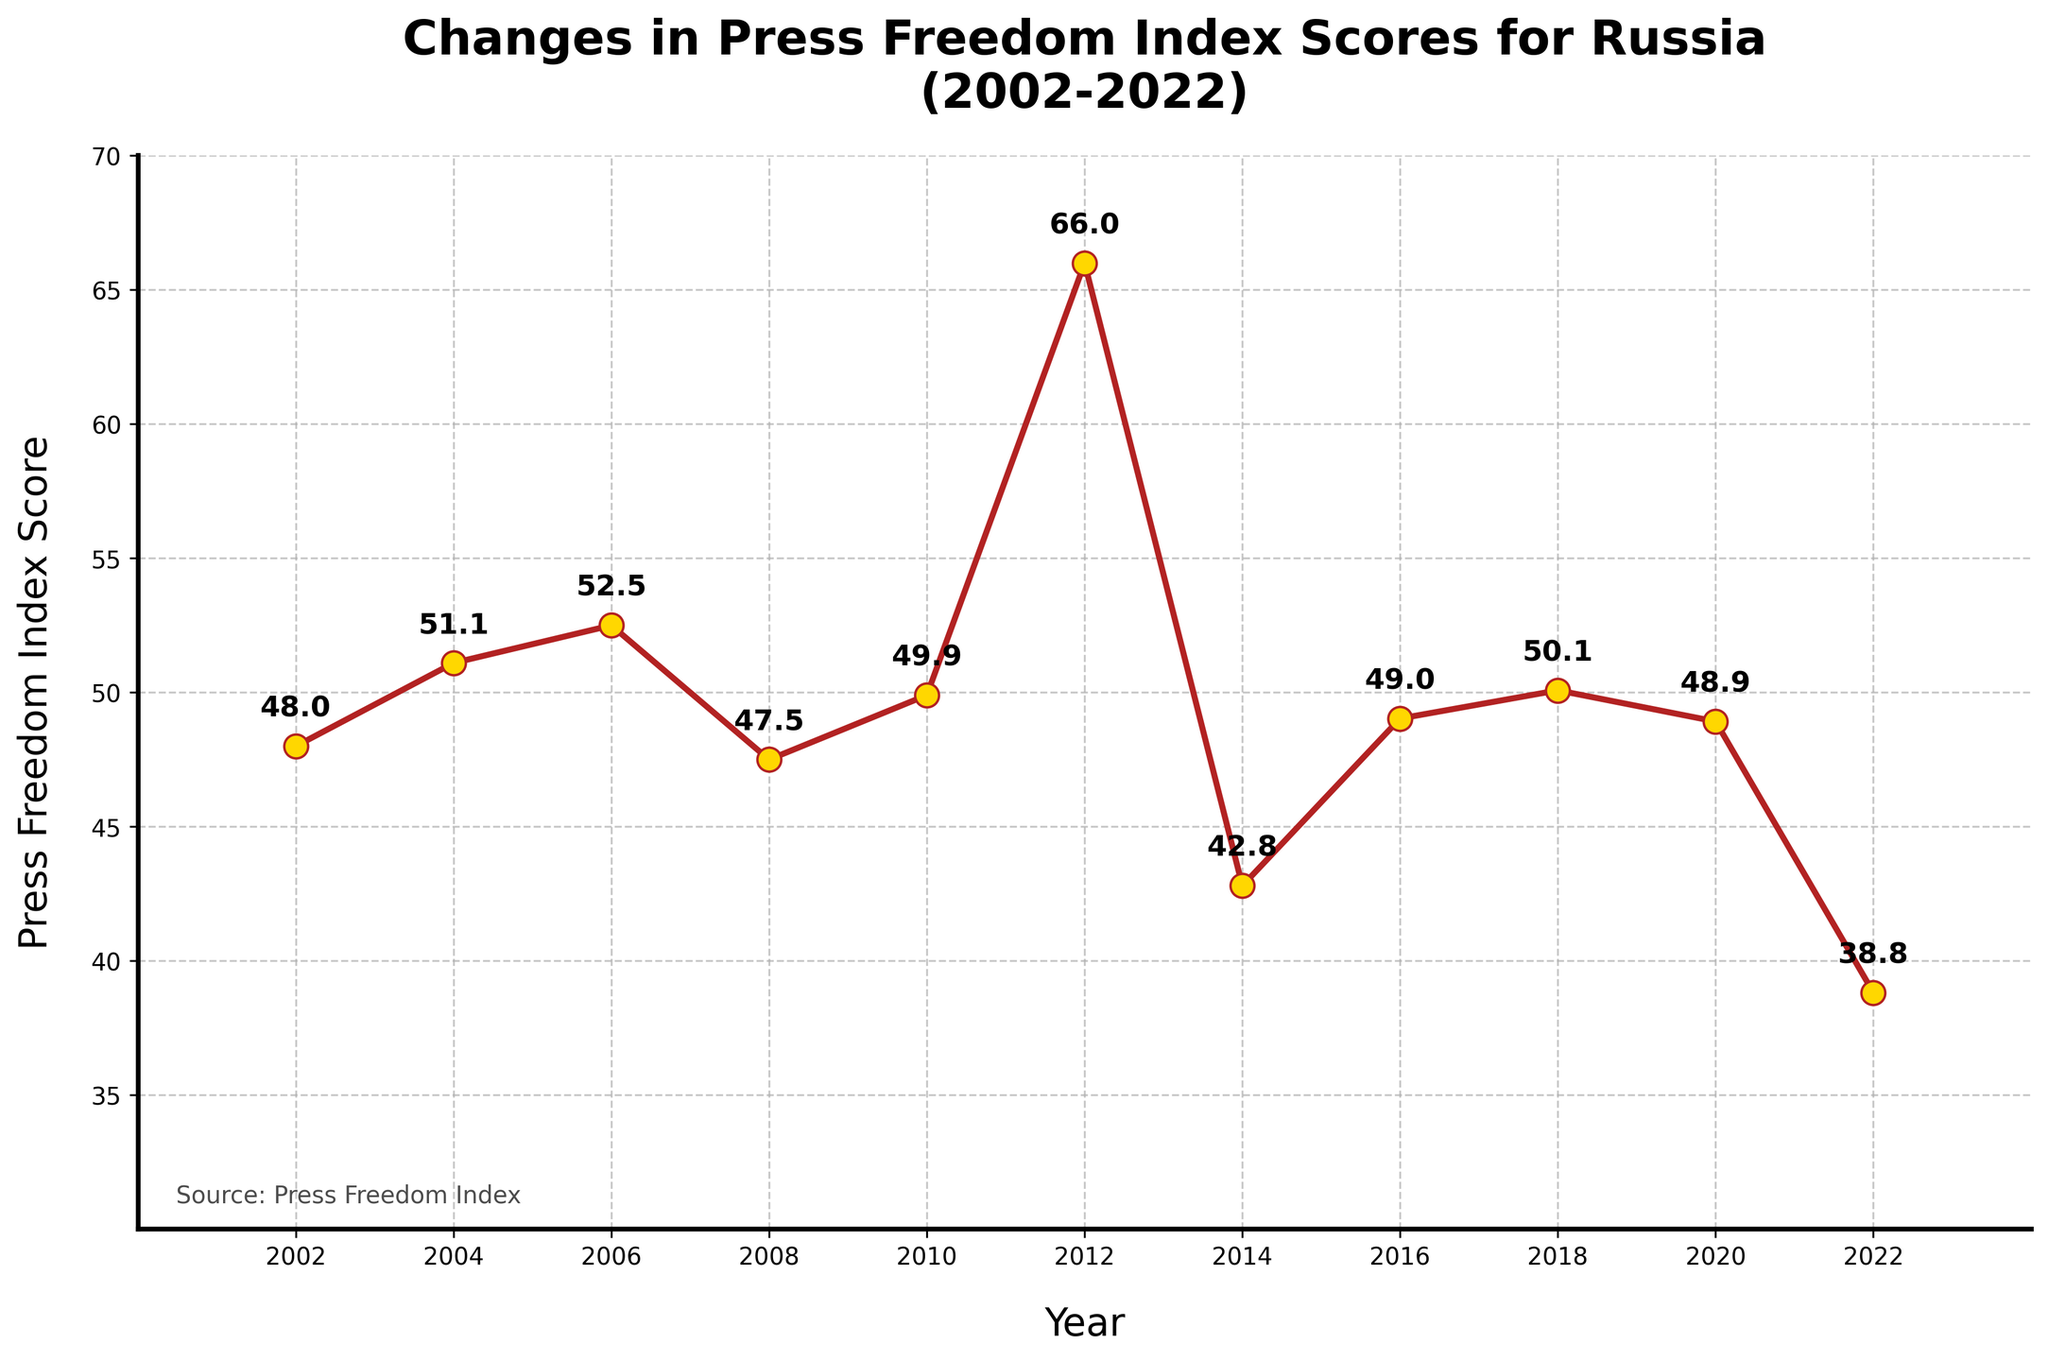What's the lowest Press Freedom Index Score recorded? The figure shows the trend of Press Freedom Index scores over the years. The lowest score can be identified by finding the minimum point along the y-axis. The lowest score is marked at the year 2022 with a value of 38.82.
Answer: 38.82 What is the trend between 2010 and 2012? Observing the line segment between 2010 and 2012 on the plot, we see an upward trend, indicating an increase in the Press Freedom Index score from 49.9 in 2010 to 66.0 in 2012.
Answer: Increase Which year saw the highest Press Freedom Index Score? By examining the peaks in the line plot, the highest point on the y-axis corresponds to the year 2012 with a score of 66.0.
Answer: 2012 By how much did the Press Freedom Index Score change from 2006 to 2008? To find the change, subtract the 2008 score from the 2006 score. The values are 52.5 in 2006 and 47.5 in 2008. Therefore, 52.5 - 47.5 equals 5.0.
Answer: 5.0 Identify the years when the Press Freedom Index Score increased consecutively. By analyzing the figure, we see consecutive increases in the years from 2002 to 2006 and from 2010 to 2012.
Answer: 2002-2006, 2010-2012 What was the average Press Freedom Index Score between 2014 and 2022? List the scores from 2014 to 2022 and calculate the average: (42.8 + 49.03 + 50.08 + 48.92 + 38.82) / 5. This simplifies to 229.65 / 5, resulting in an average score of 45.93.
Answer: 45.93 Compare the Press Freedom Index Score of 2008 and 2018. Which year had a higher score? By visually comparing the points, the scores are 47.5 in 2008 and 50.08 in 2018. Therefore, 2018 had a higher Press Freedom Index Score.
Answer: 2018 How many times did the Press Freedom Index Score decrease over 4-year periods from 2002 to 2022? Examine the graph between 2002-2006, 2006-2010, 2010-2014, 2014-2018, and 2018-2022. The scores decreased in three periods: 2006-2010, 2010-2014, and 2018-2022.
Answer: Three times What is the overall trend of the Press Freedom Index Score from 2002 to 2022? Observing the entire line plot, we see fluctuations; however, it generally trends downward from 2002 at 48.0 to 2022 at 38.82.
Answer: Downward From which year to which year did the Press Freedom Index Score drop the most significantly? Spot the steepest decline in the plot, which occurs between 2012 and 2014, with the score dropping from 66.0 to 42.8, a decline of 23.2 points.
Answer: 2012-2014 